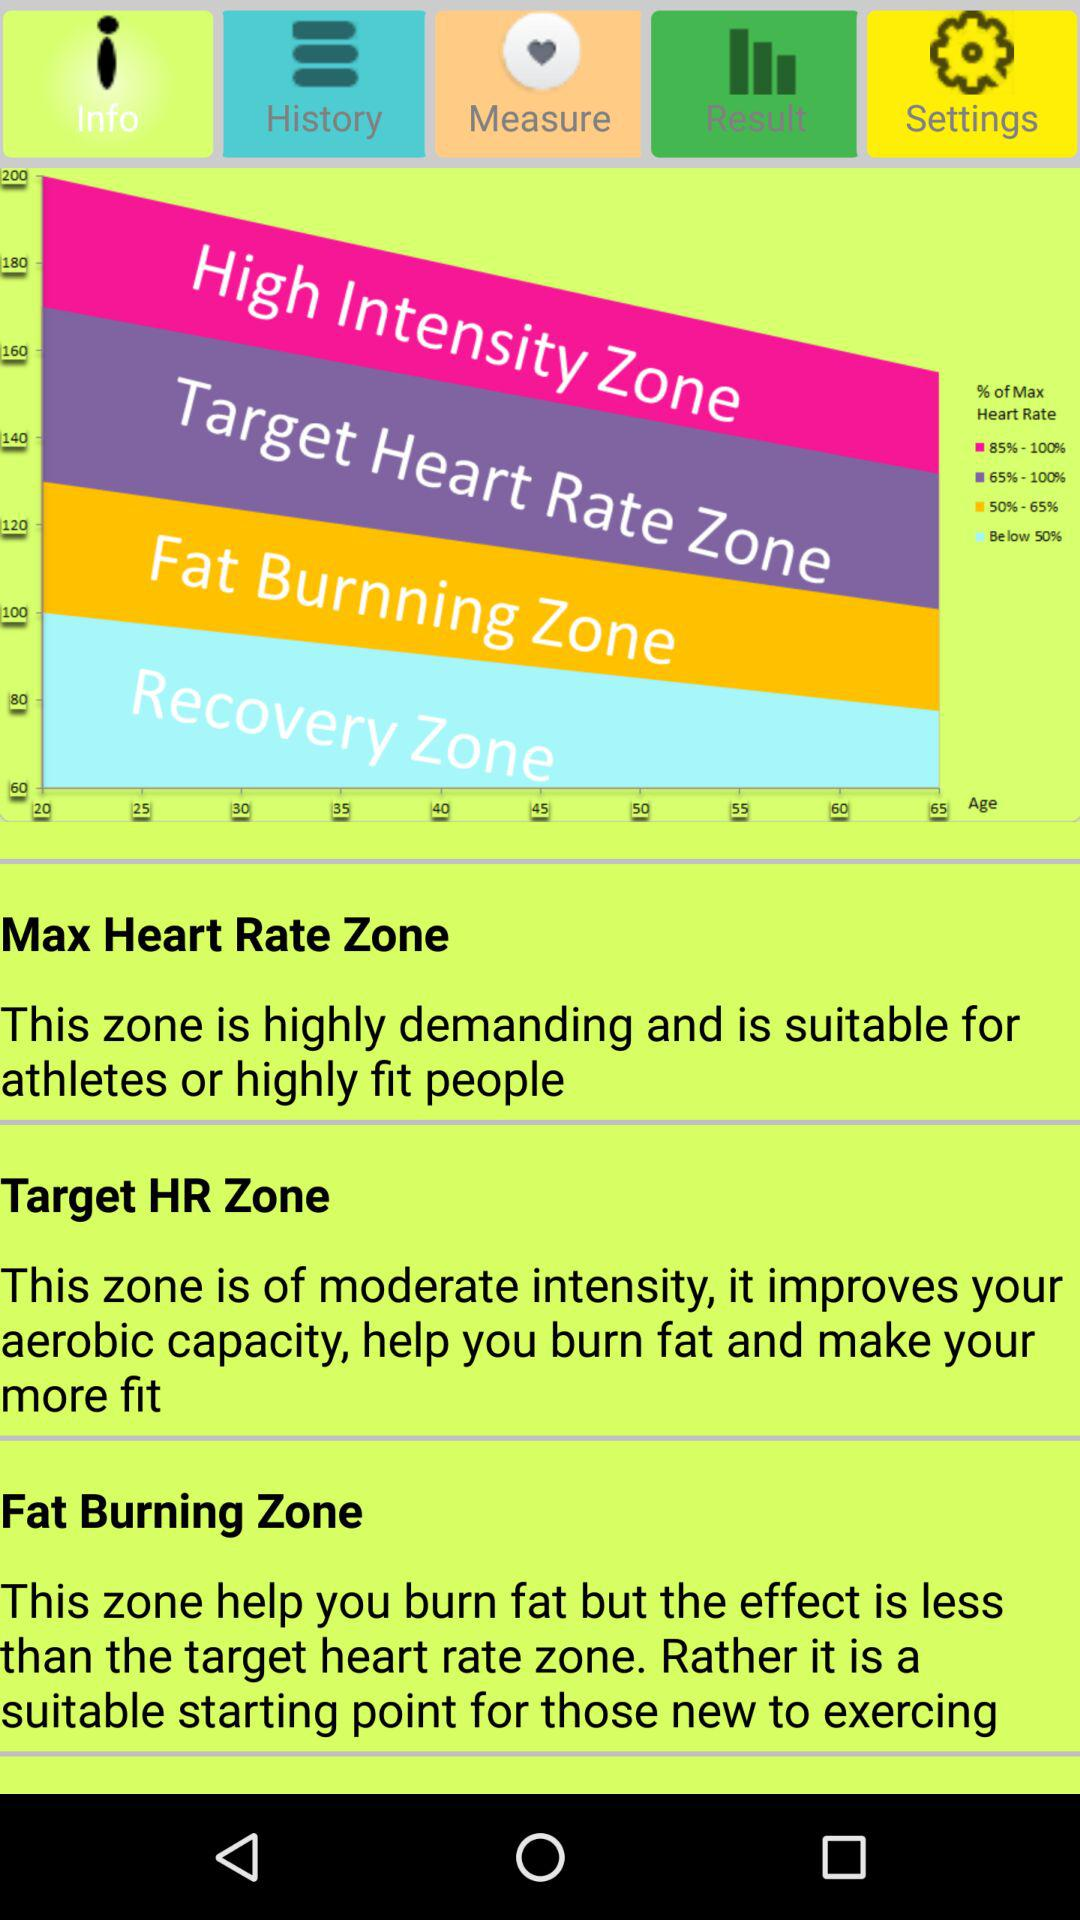What is the name of the application?
When the provided information is insufficient, respond with <no answer>. <no answer> 